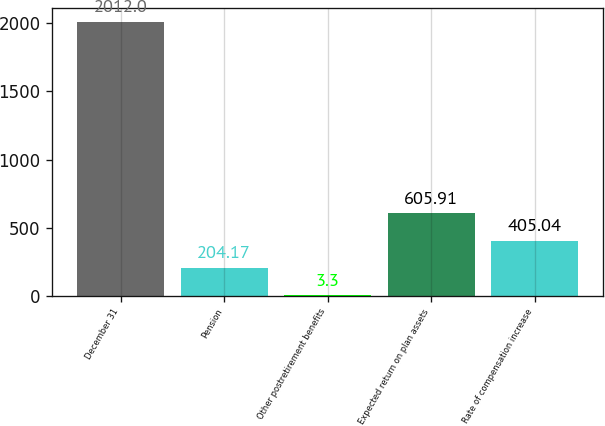Convert chart to OTSL. <chart><loc_0><loc_0><loc_500><loc_500><bar_chart><fcel>December 31<fcel>Pension<fcel>Other postretirement benefits<fcel>Expected return on plan assets<fcel>Rate of compensation increase<nl><fcel>2012<fcel>204.17<fcel>3.3<fcel>605.91<fcel>405.04<nl></chart> 